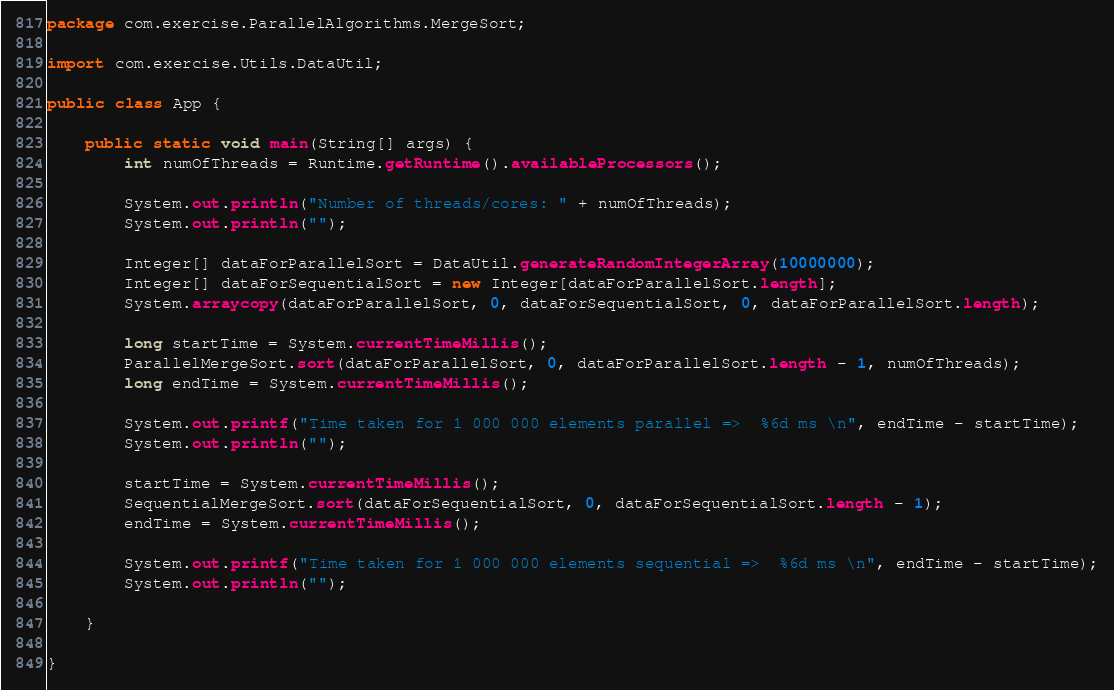<code> <loc_0><loc_0><loc_500><loc_500><_Java_>package com.exercise.ParallelAlgorithms.MergeSort;

import com.exercise.Utils.DataUtil;

public class App {

    public static void main(String[] args) {
        int numOfThreads = Runtime.getRuntime().availableProcessors();

        System.out.println("Number of threads/cores: " + numOfThreads);
        System.out.println("");

        Integer[] dataForParallelSort = DataUtil.generateRandomIntegerArray(10000000);
        Integer[] dataForSequentialSort = new Integer[dataForParallelSort.length];
        System.arraycopy(dataForParallelSort, 0, dataForSequentialSort, 0, dataForParallelSort.length);

        long startTime = System.currentTimeMillis();
        ParallelMergeSort.sort(dataForParallelSort, 0, dataForParallelSort.length - 1, numOfThreads);
        long endTime = System.currentTimeMillis();

        System.out.printf("Time taken for 1 000 000 elements parallel =>  %6d ms \n", endTime - startTime);
        System.out.println("");

        startTime = System.currentTimeMillis();
        SequentialMergeSort.sort(dataForSequentialSort, 0, dataForSequentialSort.length - 1);
        endTime = System.currentTimeMillis();

        System.out.printf("Time taken for 1 000 000 elements sequential =>  %6d ms \n", endTime - startTime);
        System.out.println("");

    }

}
</code> 